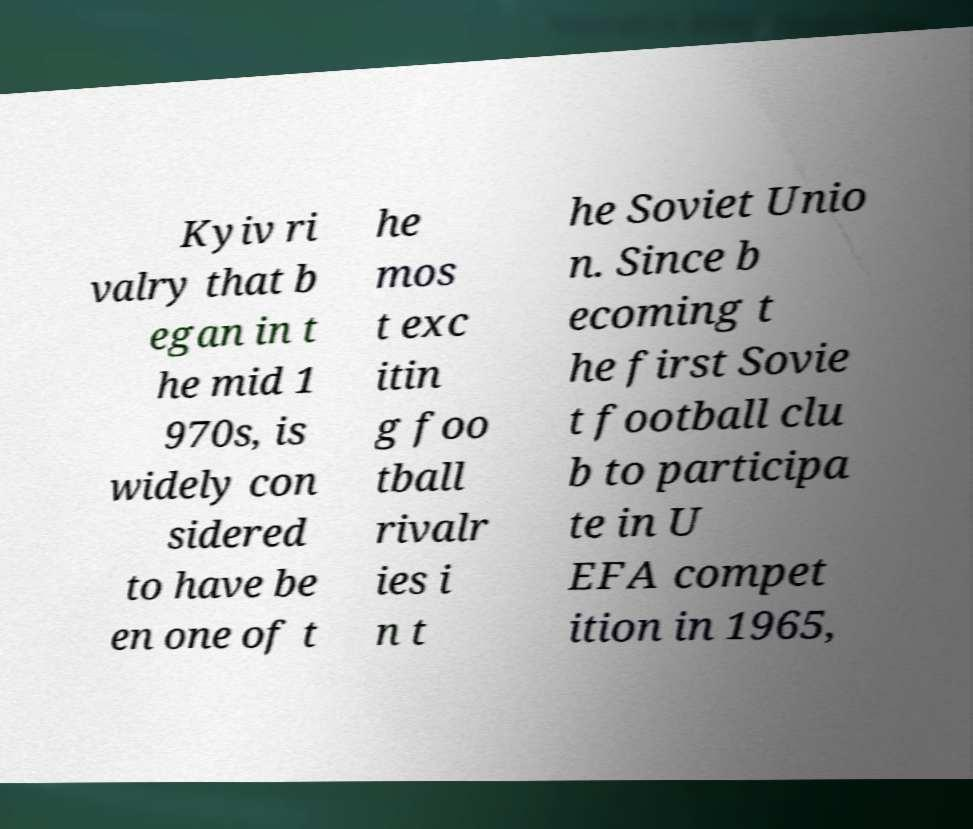Please identify and transcribe the text found in this image. Kyiv ri valry that b egan in t he mid 1 970s, is widely con sidered to have be en one of t he mos t exc itin g foo tball rivalr ies i n t he Soviet Unio n. Since b ecoming t he first Sovie t football clu b to participa te in U EFA compet ition in 1965, 